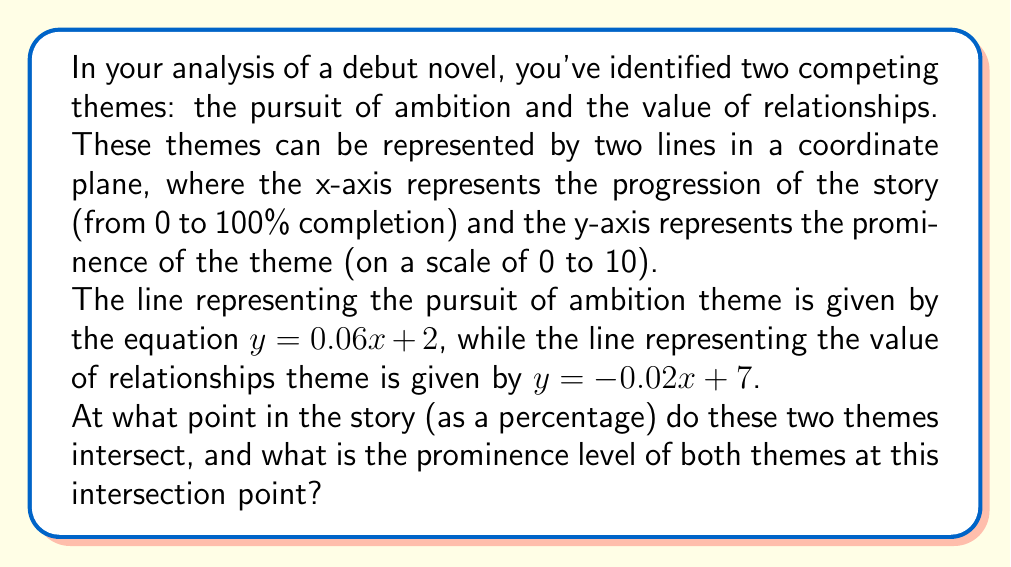Can you answer this question? To find the intersection point of these two lines, we need to solve the system of equations:

$$\begin{cases}
y = 0.06x + 2 \\
y = -0.02x + 7
\end{cases}$$

At the intersection point, the y-values are equal, so we can set the right sides of the equations equal to each other:

$$0.06x + 2 = -0.02x + 7$$

Now, let's solve for x:

$$0.06x + 0.02x = 7 - 2$$
$$0.08x = 5$$
$$x = \frac{5}{0.08} = 62.5$$

This means the themes intersect when the story is 62.5% complete.

To find the prominence level at this intersection point, we can substitute x = 62.5 into either of the original equations. Let's use the first one:

$$y = 0.06(62.5) + 2$$
$$y = 3.75 + 2 = 5.75$$

Therefore, the prominence level of both themes at the intersection point is 5.75.

[asy]
size(200,200);
import graph;

xaxis("Story progression (%)", 0, 100, Arrow);
yaxis("Theme prominence", 0, 10, Arrow);

real f(real x) {return 0.06x + 2;}
real g(real x) {return -0.02x + 7;}

draw(graph(f,0,100), blue);
draw(graph(g,0,100), red);

dot((62.5,5.75), black);
label("(62.5, 5.75)", (62.5,5.75), NE);

label("Ambition", (90,f(90)), E, blue);
label("Relationships", (90,g(90)), E, red);
[/asy]
Answer: The two themes intersect when the story is 62.5% complete, with a prominence level of 5.75 for both themes at this point. 